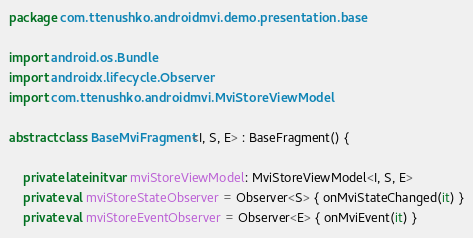Convert code to text. <code><loc_0><loc_0><loc_500><loc_500><_Kotlin_>package com.ttenushko.androidmvi.demo.presentation.base

import android.os.Bundle
import androidx.lifecycle.Observer
import com.ttenushko.androidmvi.MviStoreViewModel

abstract class BaseMviFragment<I, S, E> : BaseFragment() {

    private lateinit var mviStoreViewModel: MviStoreViewModel<I, S, E>
    private val mviStoreStateObserver = Observer<S> { onMviStateChanged(it) }
    private val mviStoreEventObserver = Observer<E> { onMviEvent(it) }
</code> 